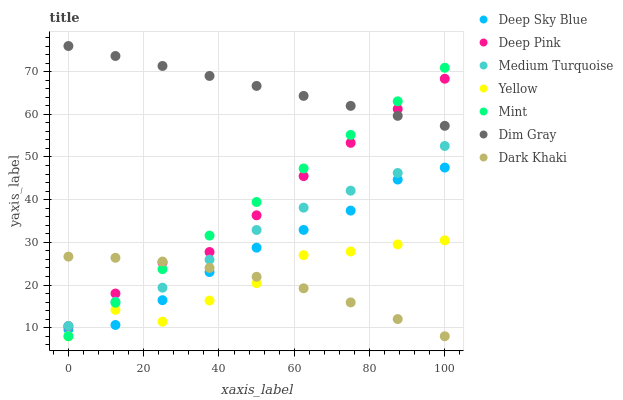Does Dark Khaki have the minimum area under the curve?
Answer yes or no. Yes. Does Dim Gray have the maximum area under the curve?
Answer yes or no. Yes. Does Deep Sky Blue have the minimum area under the curve?
Answer yes or no. No. Does Deep Sky Blue have the maximum area under the curve?
Answer yes or no. No. Is Dim Gray the smoothest?
Answer yes or no. Yes. Is Yellow the roughest?
Answer yes or no. Yes. Is Deep Sky Blue the smoothest?
Answer yes or no. No. Is Deep Sky Blue the roughest?
Answer yes or no. No. Does Yellow have the lowest value?
Answer yes or no. Yes. Does Deep Sky Blue have the lowest value?
Answer yes or no. No. Does Dim Gray have the highest value?
Answer yes or no. Yes. Does Deep Sky Blue have the highest value?
Answer yes or no. No. Is Deep Sky Blue less than Deep Pink?
Answer yes or no. Yes. Is Medium Turquoise greater than Yellow?
Answer yes or no. Yes. Does Dim Gray intersect Deep Pink?
Answer yes or no. Yes. Is Dim Gray less than Deep Pink?
Answer yes or no. No. Is Dim Gray greater than Deep Pink?
Answer yes or no. No. Does Deep Sky Blue intersect Deep Pink?
Answer yes or no. No. 